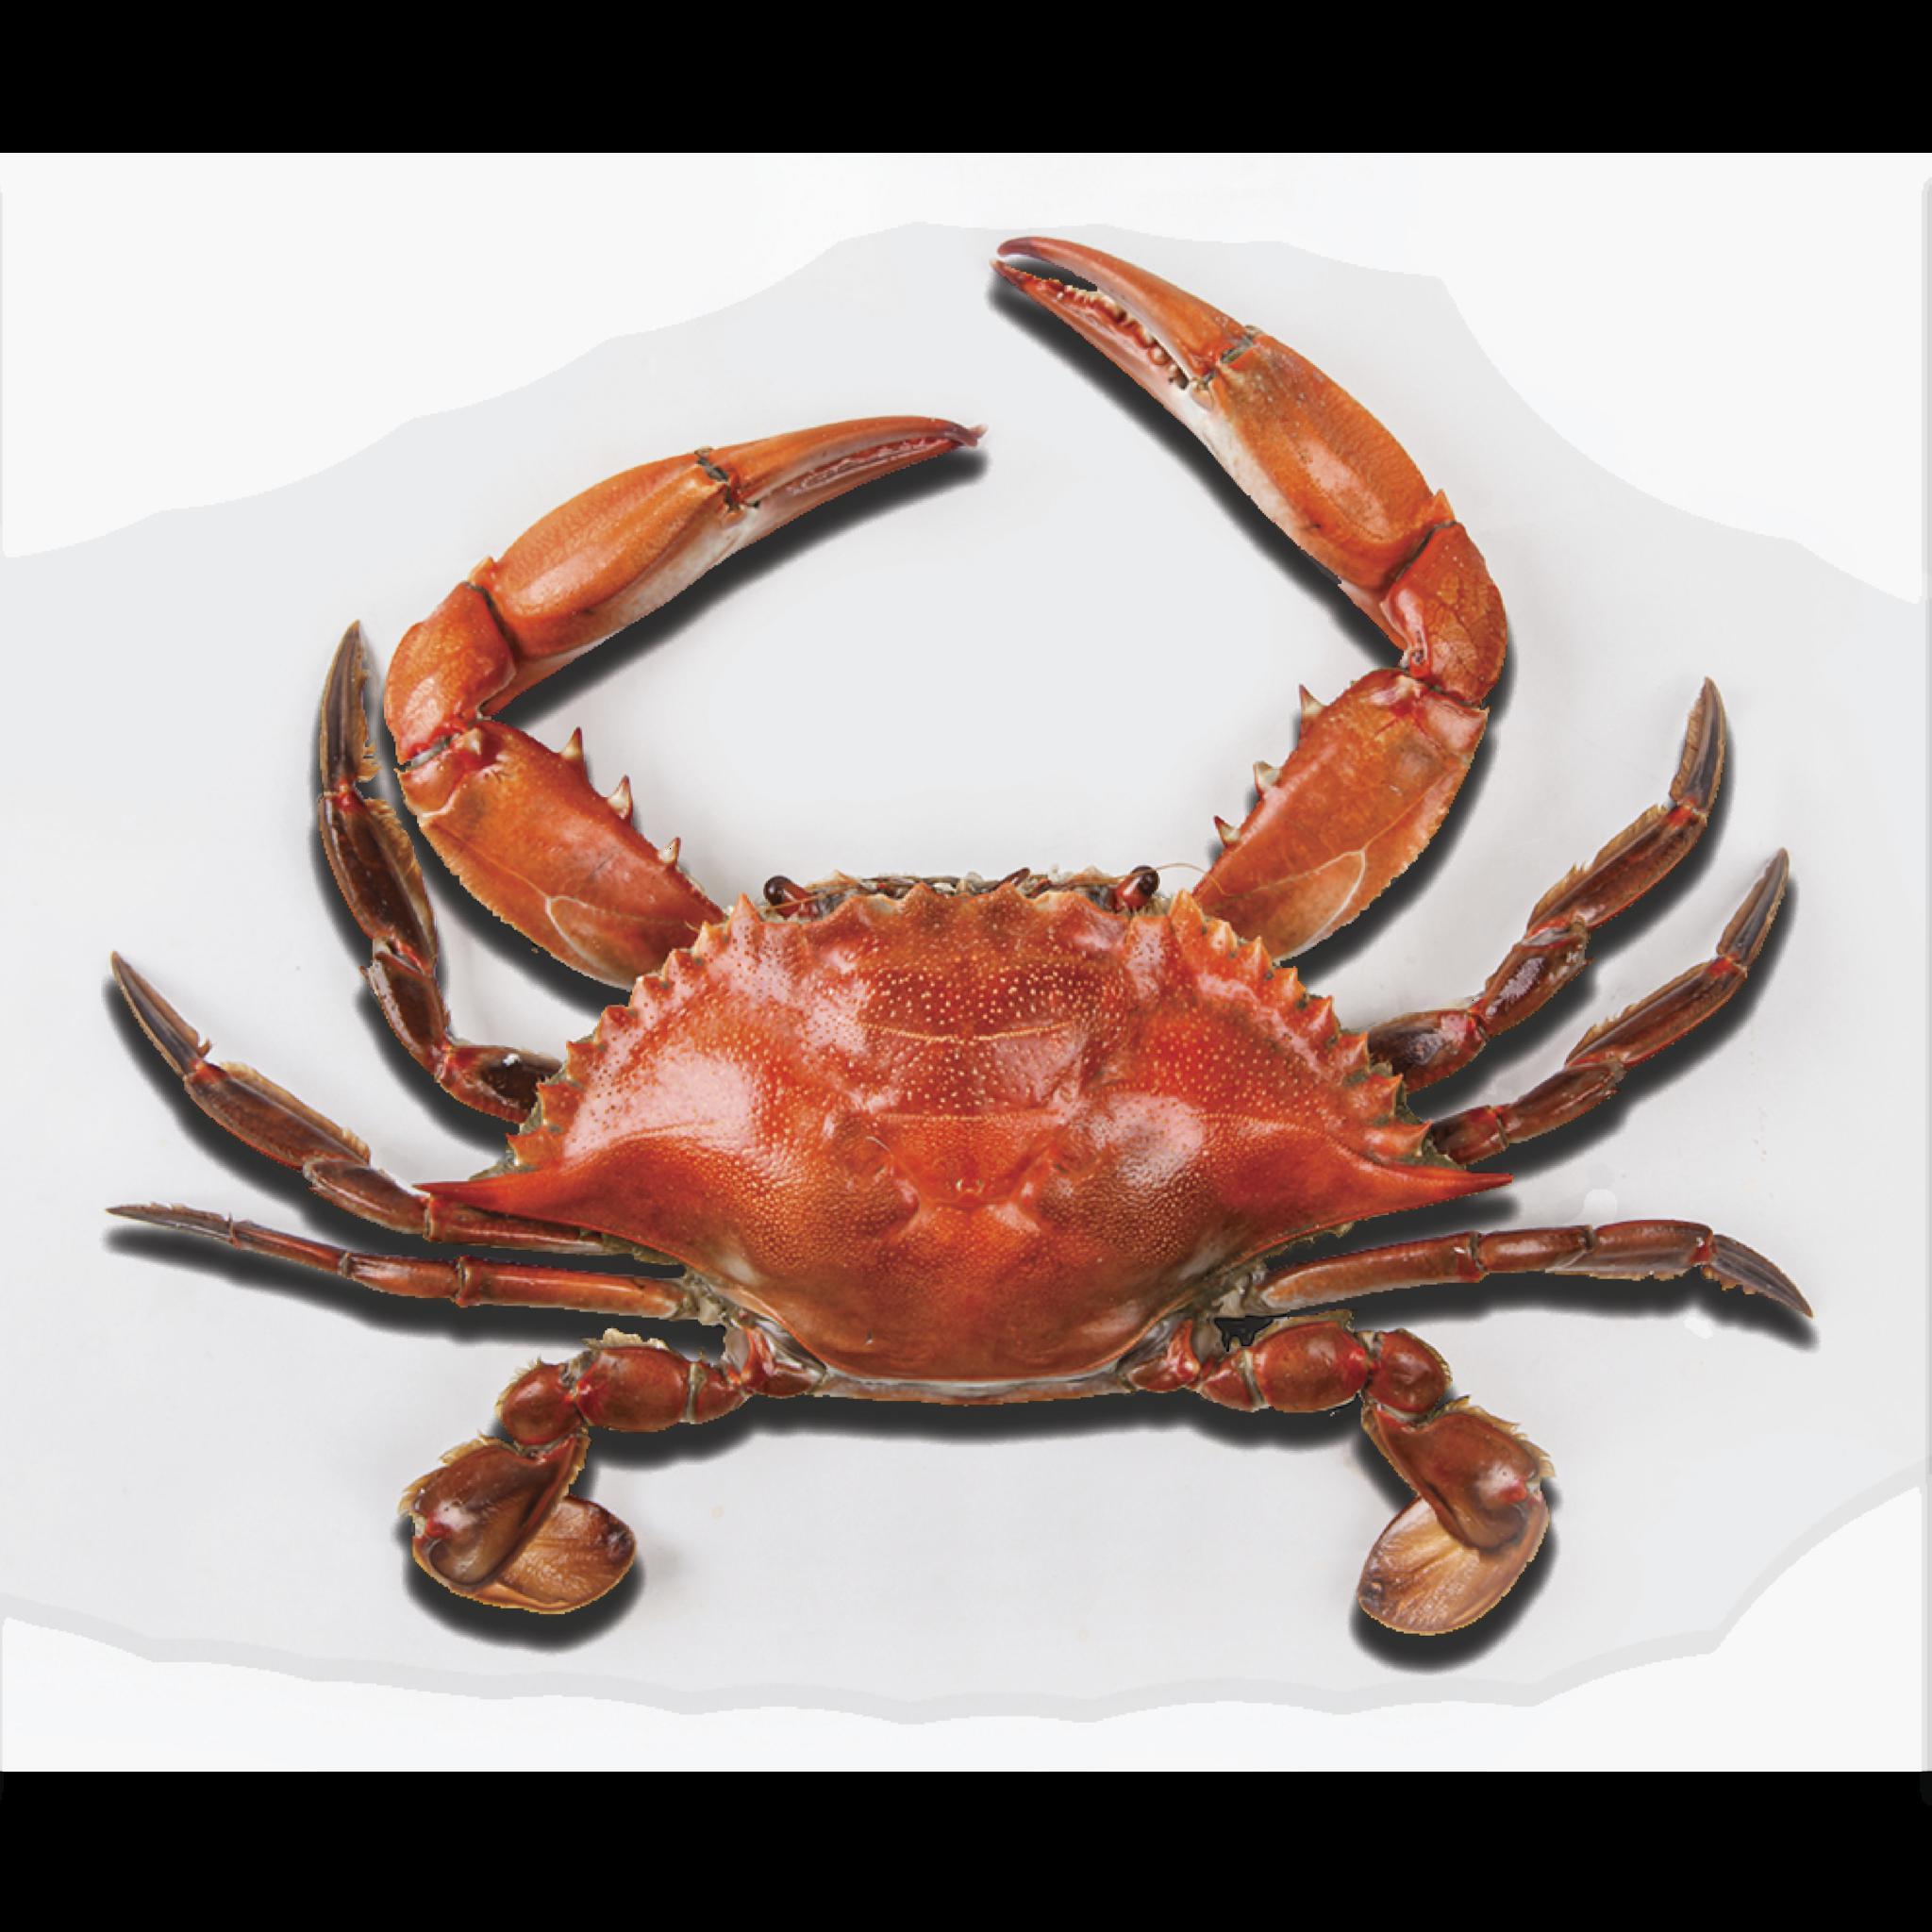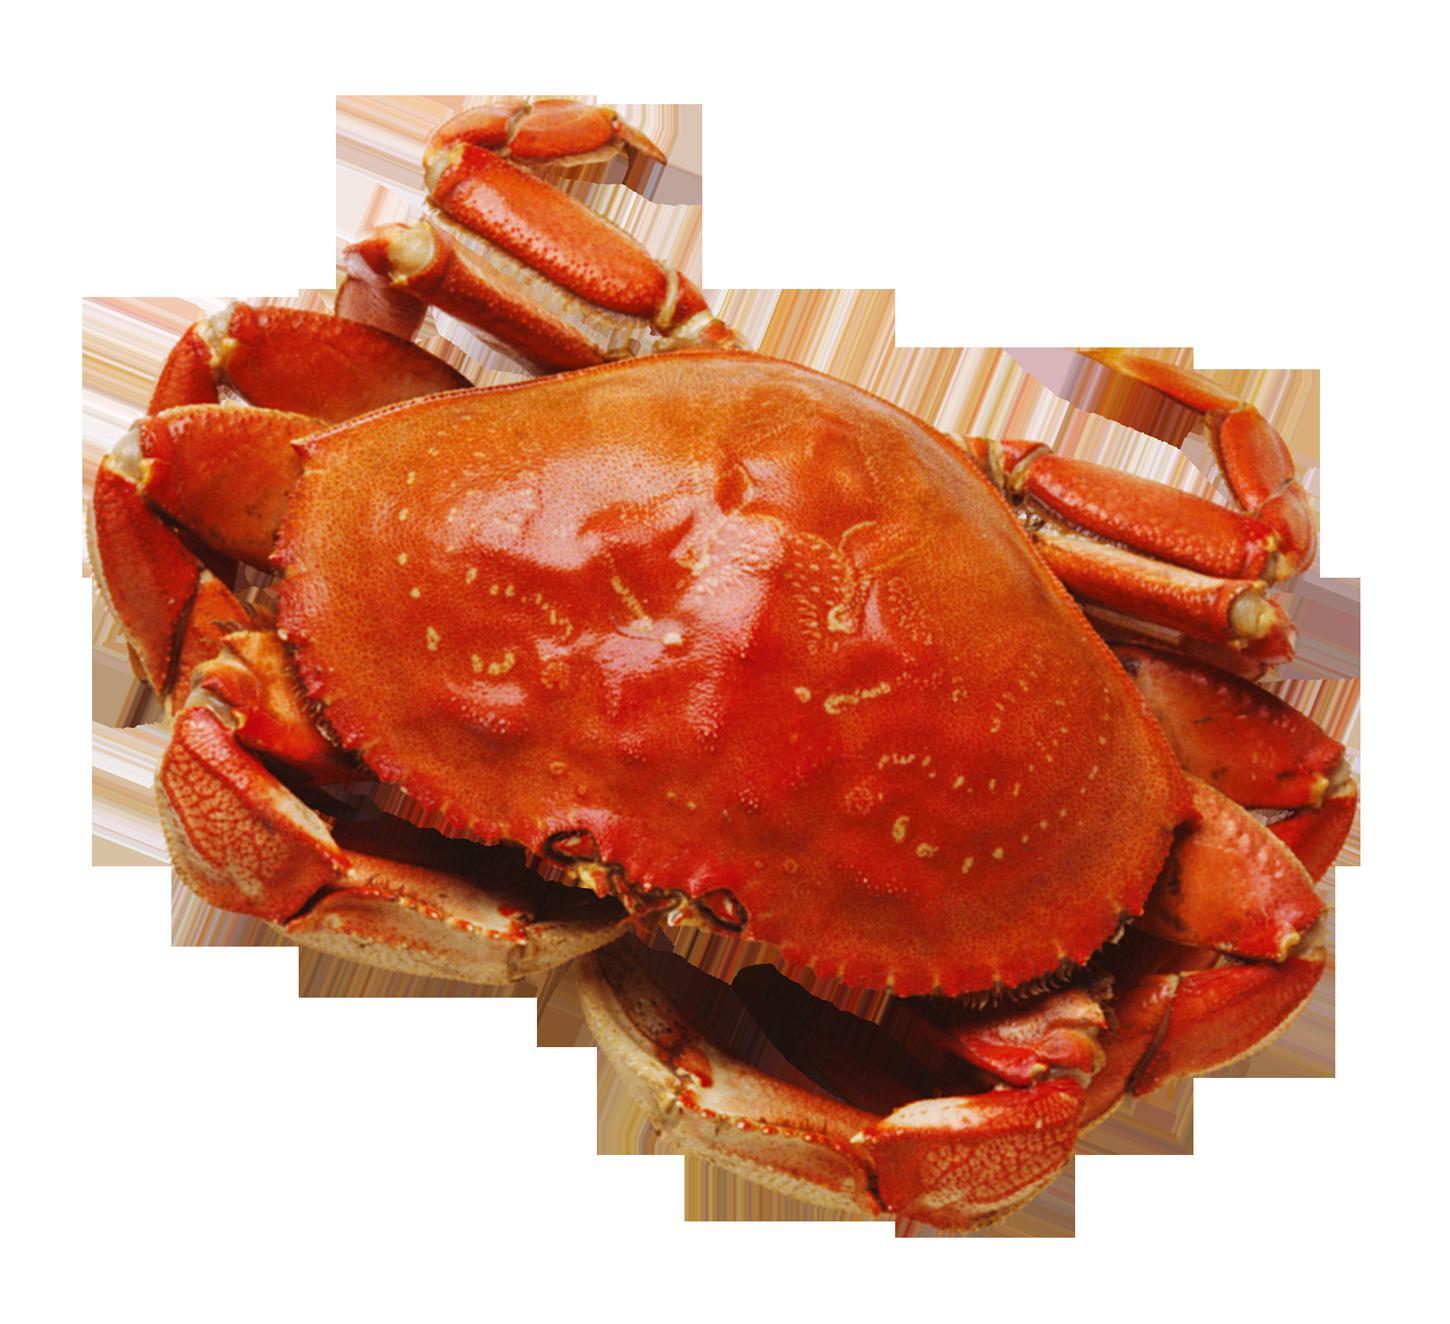The first image is the image on the left, the second image is the image on the right. Considering the images on both sides, is "there are two cooked crabs in the image pair" valid? Answer yes or no. Yes. The first image is the image on the left, the second image is the image on the right. Given the left and right images, does the statement "Both crabs are orange." hold true? Answer yes or no. Yes. 